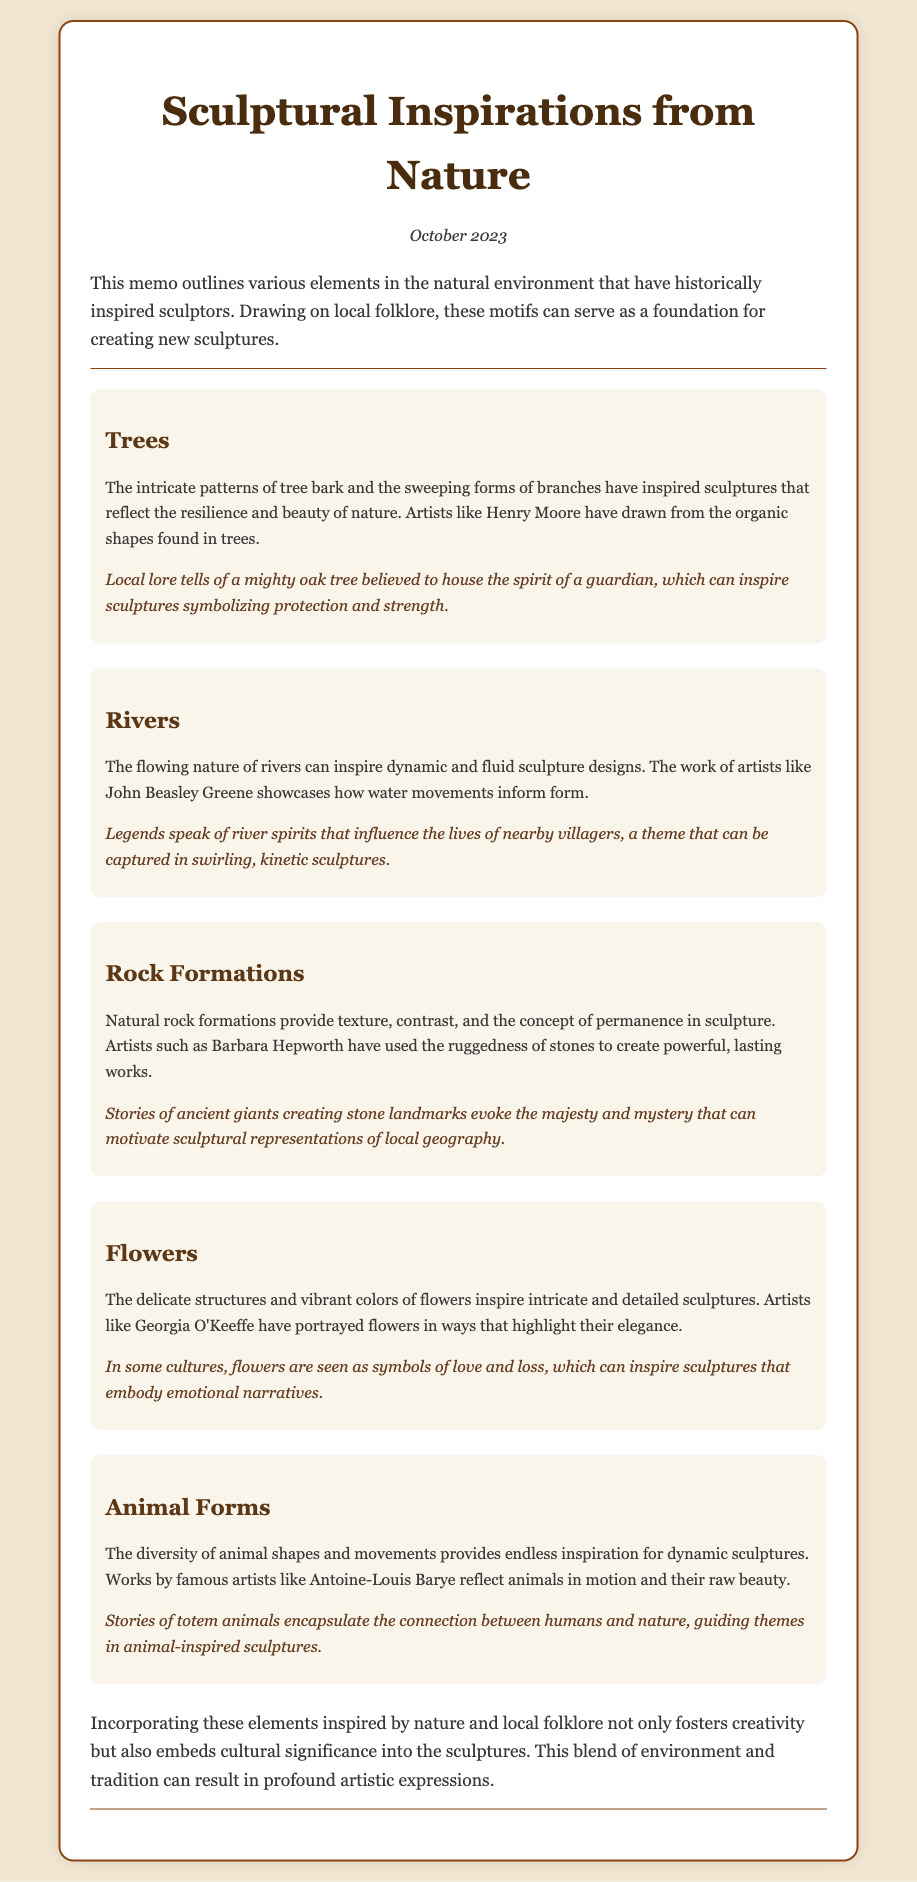What month and year was the memo created? The memo explicitly states the created date at the top.
Answer: October 2023 Which artist is mentioned in connection with trees? The memo describes how Henry Moore draws inspiration from trees.
Answer: Henry Moore What natural element is associated with dynamic and fluid sculpture designs? The memo discusses how rivers inform fluid sculpture designs.
Answer: Rivers Name one artist associated with rock formations. The document mentions Barbara Hepworth in relation to rock formations.
Answer: Barbara Hepworth What is a folklore theme related to flowers? The document mentions that flowers can symbolize love and loss in some cultures.
Answer: Love and loss Which animal-related theme is referenced in the document? The document talks about stories of totem animals that guide themes in sculpture.
Answer: Totem animals What does the document suggest incorporating to foster creativity in sculptures? The memo advises incorporating elements from nature and local folklore.
Answer: Nature and local folklore How does the memo describe the significance of combining nature and tradition in sculptures? The conclusion mentions that it results in profound artistic expressions.
Answer: Profound artistic expressions 